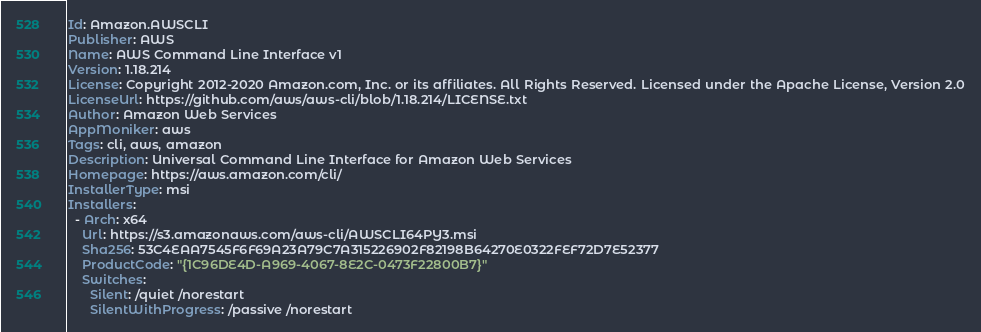Convert code to text. <code><loc_0><loc_0><loc_500><loc_500><_YAML_>Id: Amazon.AWSCLI
Publisher: AWS
Name: AWS Command Line Interface v1
Version: 1.18.214
License: Copyright 2012-2020 Amazon.com, Inc. or its affiliates. All Rights Reserved. Licensed under the Apache License, Version 2.0
LicenseUrl: https://github.com/aws/aws-cli/blob/1.18.214/LICENSE.txt
Author: Amazon Web Services
AppMoniker: aws
Tags: cli, aws, amazon
Description: Universal Command Line Interface for Amazon Web Services
Homepage: https://aws.amazon.com/cli/
InstallerType: msi
Installers:
  - Arch: x64
    Url: https://s3.amazonaws.com/aws-cli/AWSCLI64PY3.msi
    Sha256: 53C4EAA7545F6F69A23A79C7A315226902F82198B64270E0322FEF72D7E52377
    ProductCode: "{1C96DE4D-A969-4067-8E2C-0473F22800B7}"
    Switches:
      Silent: /quiet /norestart
      SilentWithProgress: /passive /norestart
</code> 